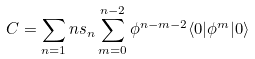<formula> <loc_0><loc_0><loc_500><loc_500>C = \sum _ { n = 1 } n s _ { n } \sum _ { m = 0 } ^ { n - 2 } \phi ^ { n - m - 2 } \langle 0 | \phi ^ { m } | 0 \rangle</formula> 